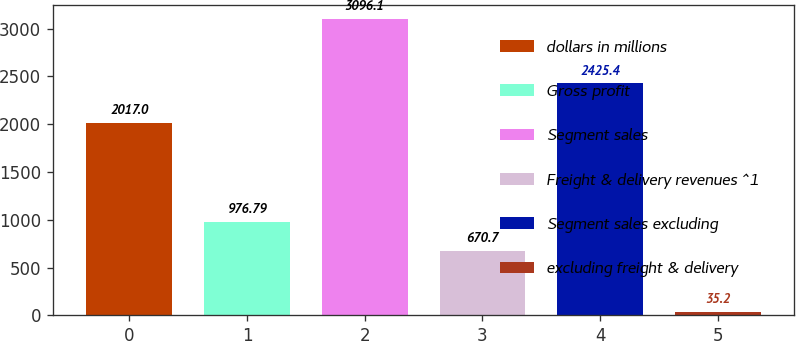<chart> <loc_0><loc_0><loc_500><loc_500><bar_chart><fcel>dollars in millions<fcel>Gross profit<fcel>Segment sales<fcel>Freight & delivery revenues ^1<fcel>Segment sales excluding<fcel>excluding freight & delivery<nl><fcel>2017<fcel>976.79<fcel>3096.1<fcel>670.7<fcel>2425.4<fcel>35.2<nl></chart> 